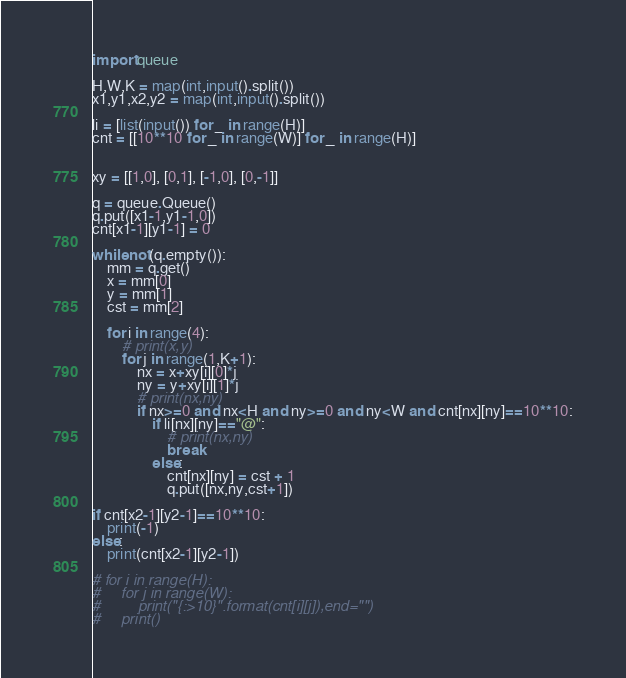Convert code to text. <code><loc_0><loc_0><loc_500><loc_500><_Python_>import queue

H,W,K = map(int,input().split())
x1,y1,x2,y2 = map(int,input().split())

li = [list(input()) for _ in range(H)]
cnt = [[10**10 for _ in range(W)] for _ in range(H)]


xy = [[1,0], [0,1], [-1,0], [0,-1]]

q = queue.Queue()
q.put([x1-1,y1-1,0])
cnt[x1-1][y1-1] = 0

while not(q.empty()):
    mm = q.get()
    x = mm[0]
    y = mm[1]
    cst = mm[2]

    for i in range(4):
        # print(x,y)
        for j in range(1,K+1):
            nx = x+xy[i][0]*j
            ny = y+xy[i][1]*j
            # print(nx,ny)
            if nx>=0 and nx<H and ny>=0 and ny<W and cnt[nx][ny]==10**10:
                if li[nx][ny]=="@":
                    # print(nx,ny)
                    break
                else:
                    cnt[nx][ny] = cst + 1
                    q.put([nx,ny,cst+1])

if cnt[x2-1][y2-1]==10**10:
    print(-1)
else:
    print(cnt[x2-1][y2-1])

# for i in range(H):
#     for j in range(W):
#         print("{:>10}".format(cnt[i][j]),end="")
#     print()



</code> 